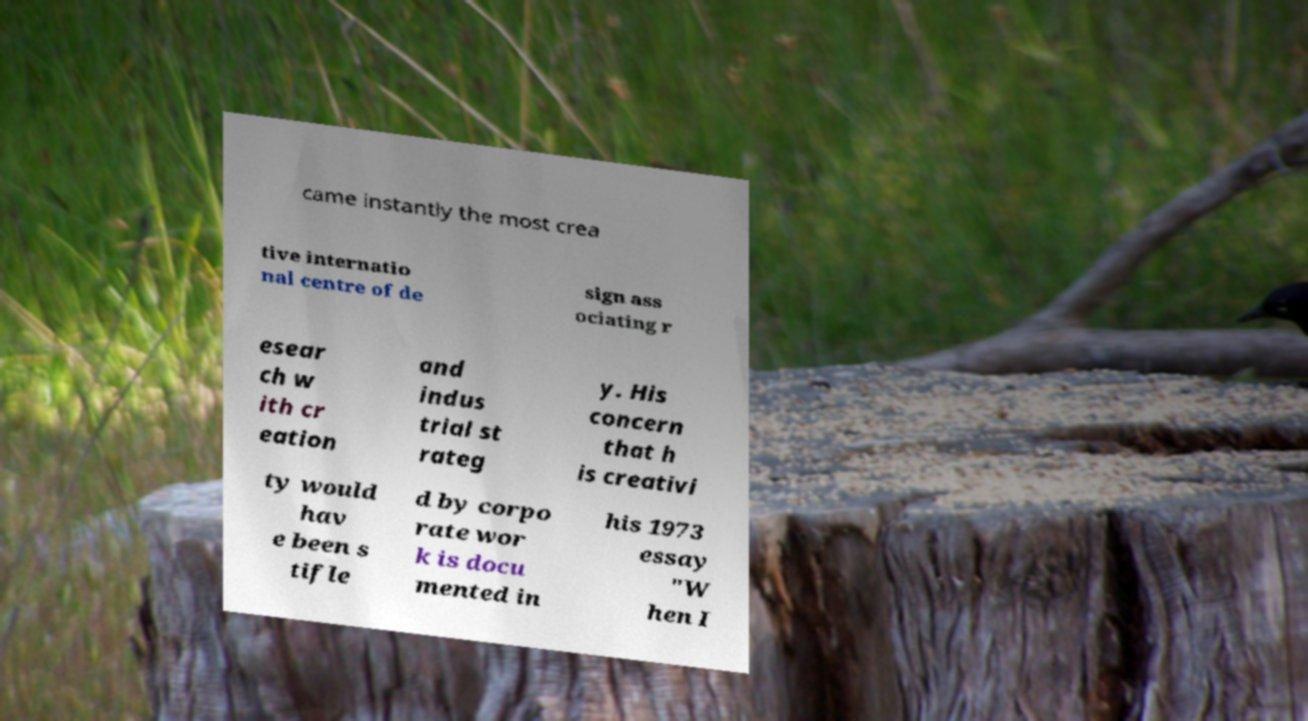Can you accurately transcribe the text from the provided image for me? came instantly the most crea tive internatio nal centre of de sign ass ociating r esear ch w ith cr eation and indus trial st rateg y. His concern that h is creativi ty would hav e been s tifle d by corpo rate wor k is docu mented in his 1973 essay "W hen I 